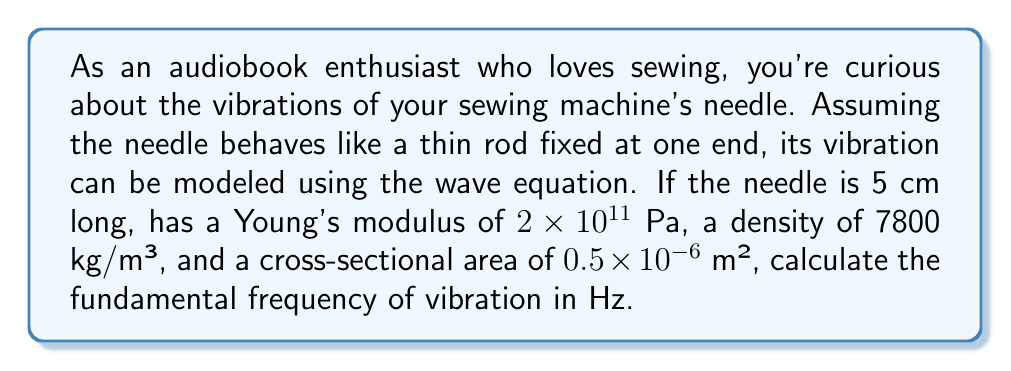Help me with this question. To solve this problem, we'll use the wave equation for a thin rod fixed at one end:

1) The wave equation for transverse vibrations in a thin rod is:

   $$\frac{\partial^2 y}{\partial t^2} = c^2 \frac{\partial^2 y}{\partial x^2}$$

   where $c = \sqrt{\frac{E}{\rho}}$ is the wave speed, $E$ is Young's modulus, and $\rho$ is density.

2) For a rod fixed at one end, the fundamental frequency is given by:

   $$f_1 = \frac{1}{4L} \sqrt{\frac{E}{\rho}}$$

   where $L$ is the length of the rod.

3) Let's substitute the given values:
   $L = 0.05$ m
   $E = 2 \times 10^{11}$ Pa
   $\rho = 7800$ kg/m³

4) Calculate the fundamental frequency:

   $$f_1 = \frac{1}{4 \times 0.05} \sqrt{\frac{2 \times 10^{11}}{7800}}$$

5) Simplify:

   $$f_1 = 5 \sqrt{\frac{2 \times 10^{11}}{7800}} = 5 \times 5064.7 = 25,323.5$$

6) Round to the nearest whole number:

   $f_1 \approx 25,324$ Hz
Answer: 25,324 Hz 